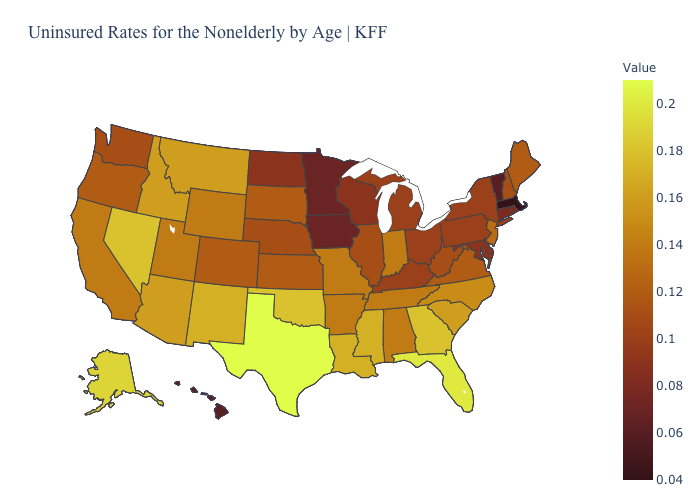Which states hav the highest value in the West?
Keep it brief. Alaska. Does Indiana have the highest value in the MidWest?
Short answer required. Yes. Among the states that border Iowa , does South Dakota have the highest value?
Be succinct. No. Among the states that border Wisconsin , which have the highest value?
Quick response, please. Illinois. Does Massachusetts have the lowest value in the USA?
Quick response, please. Yes. 